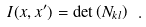<formula> <loc_0><loc_0><loc_500><loc_500>I ( x , x ^ { \prime } ) = \det \left ( N _ { k l } \right ) \ .</formula> 